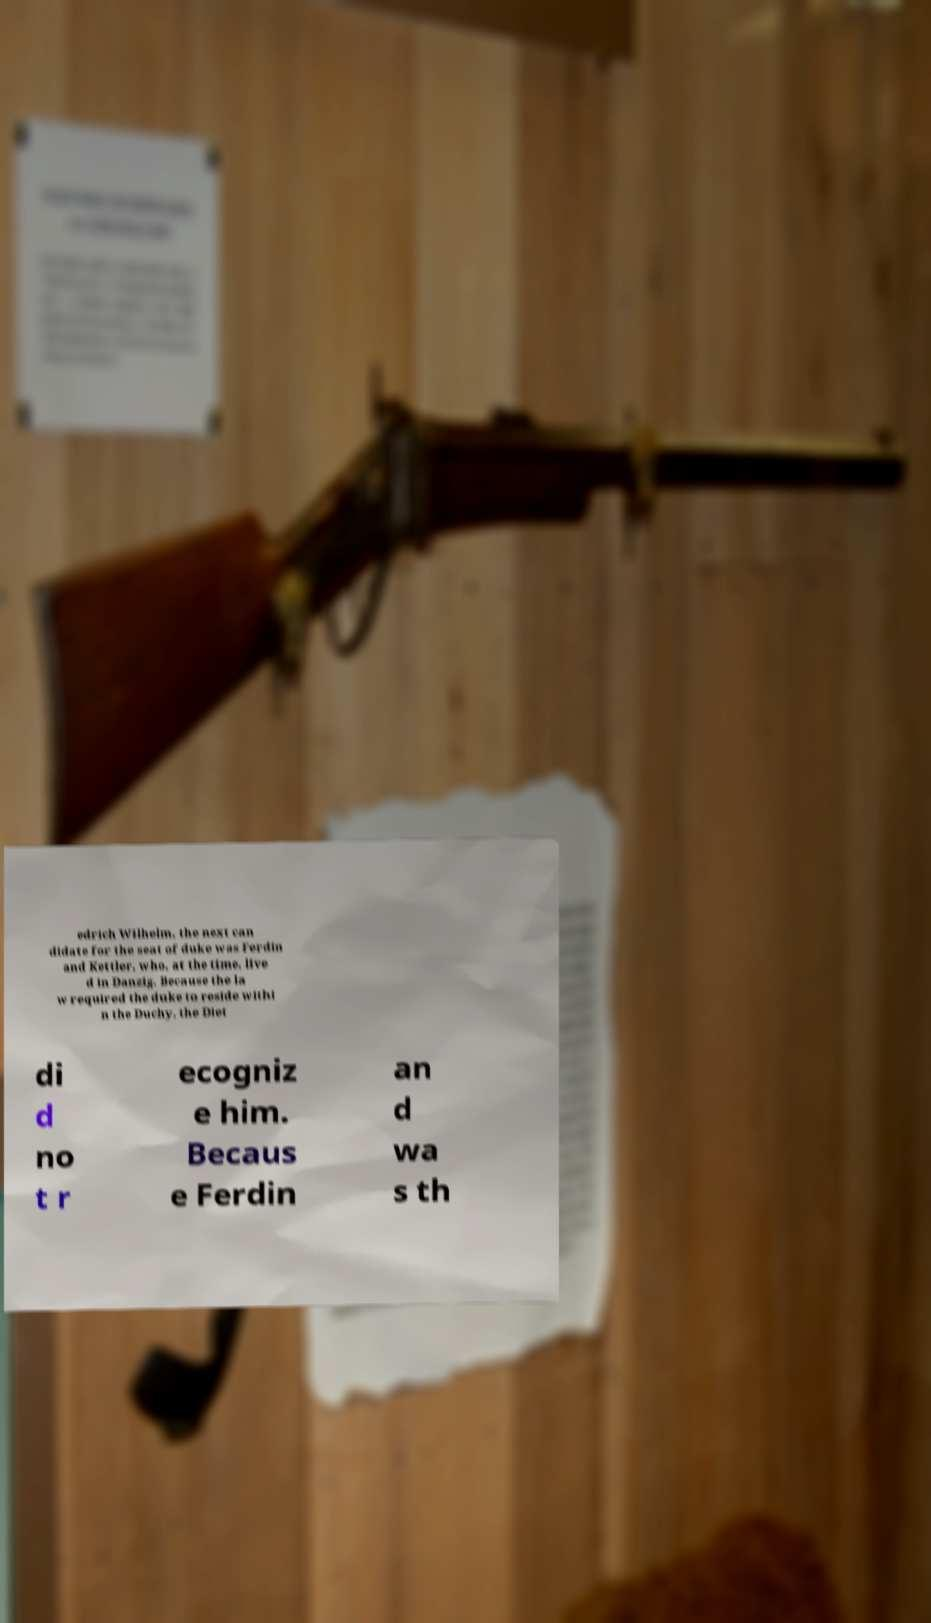Could you assist in decoding the text presented in this image and type it out clearly? edrich Wilhelm, the next can didate for the seat of duke was Ferdin and Kettler, who, at the time, live d in Danzig. Because the la w required the duke to reside withi n the Duchy, the Diet di d no t r ecogniz e him. Becaus e Ferdin an d wa s th 